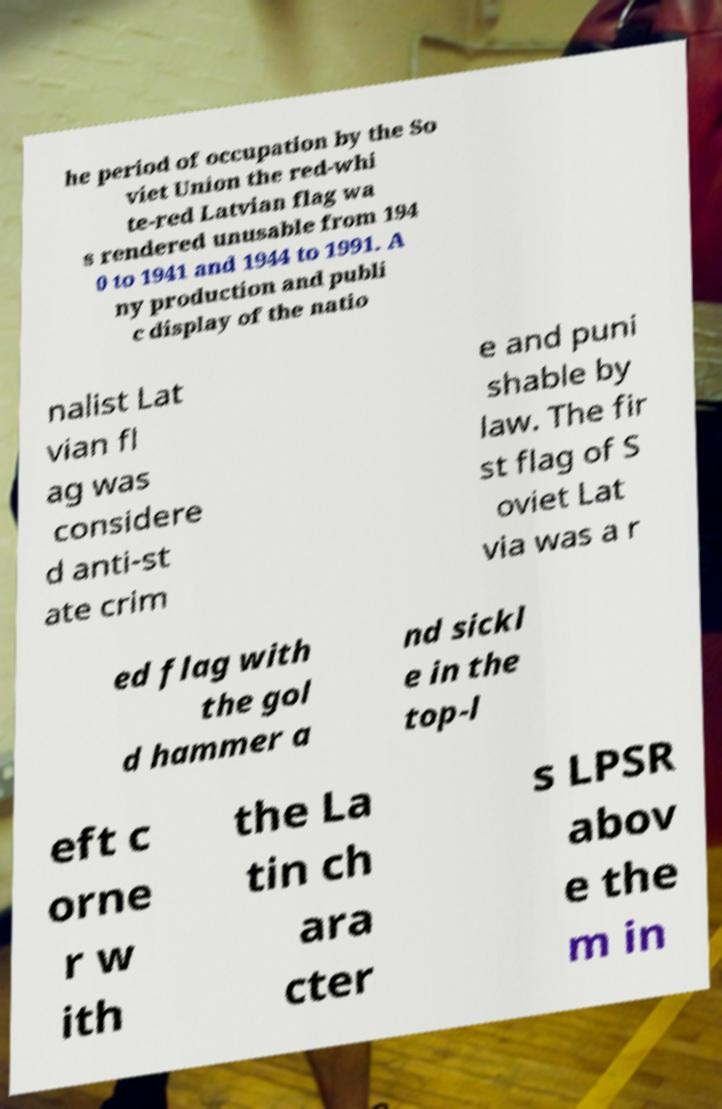There's text embedded in this image that I need extracted. Can you transcribe it verbatim? he period of occupation by the So viet Union the red-whi te-red Latvian flag wa s rendered unusable from 194 0 to 1941 and 1944 to 1991. A ny production and publi c display of the natio nalist Lat vian fl ag was considere d anti-st ate crim e and puni shable by law. The fir st flag of S oviet Lat via was a r ed flag with the gol d hammer a nd sickl e in the top-l eft c orne r w ith the La tin ch ara cter s LPSR abov e the m in 